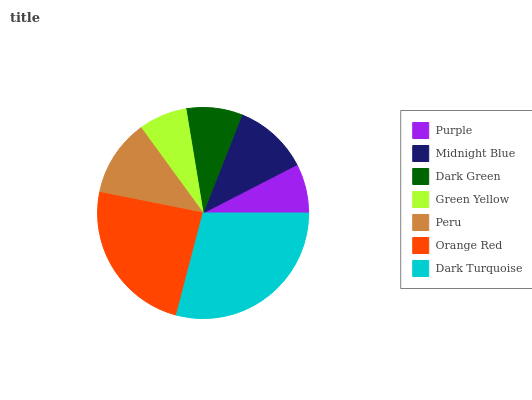Is Green Yellow the minimum?
Answer yes or no. Yes. Is Dark Turquoise the maximum?
Answer yes or no. Yes. Is Midnight Blue the minimum?
Answer yes or no. No. Is Midnight Blue the maximum?
Answer yes or no. No. Is Midnight Blue greater than Purple?
Answer yes or no. Yes. Is Purple less than Midnight Blue?
Answer yes or no. Yes. Is Purple greater than Midnight Blue?
Answer yes or no. No. Is Midnight Blue less than Purple?
Answer yes or no. No. Is Midnight Blue the high median?
Answer yes or no. Yes. Is Midnight Blue the low median?
Answer yes or no. Yes. Is Orange Red the high median?
Answer yes or no. No. Is Orange Red the low median?
Answer yes or no. No. 